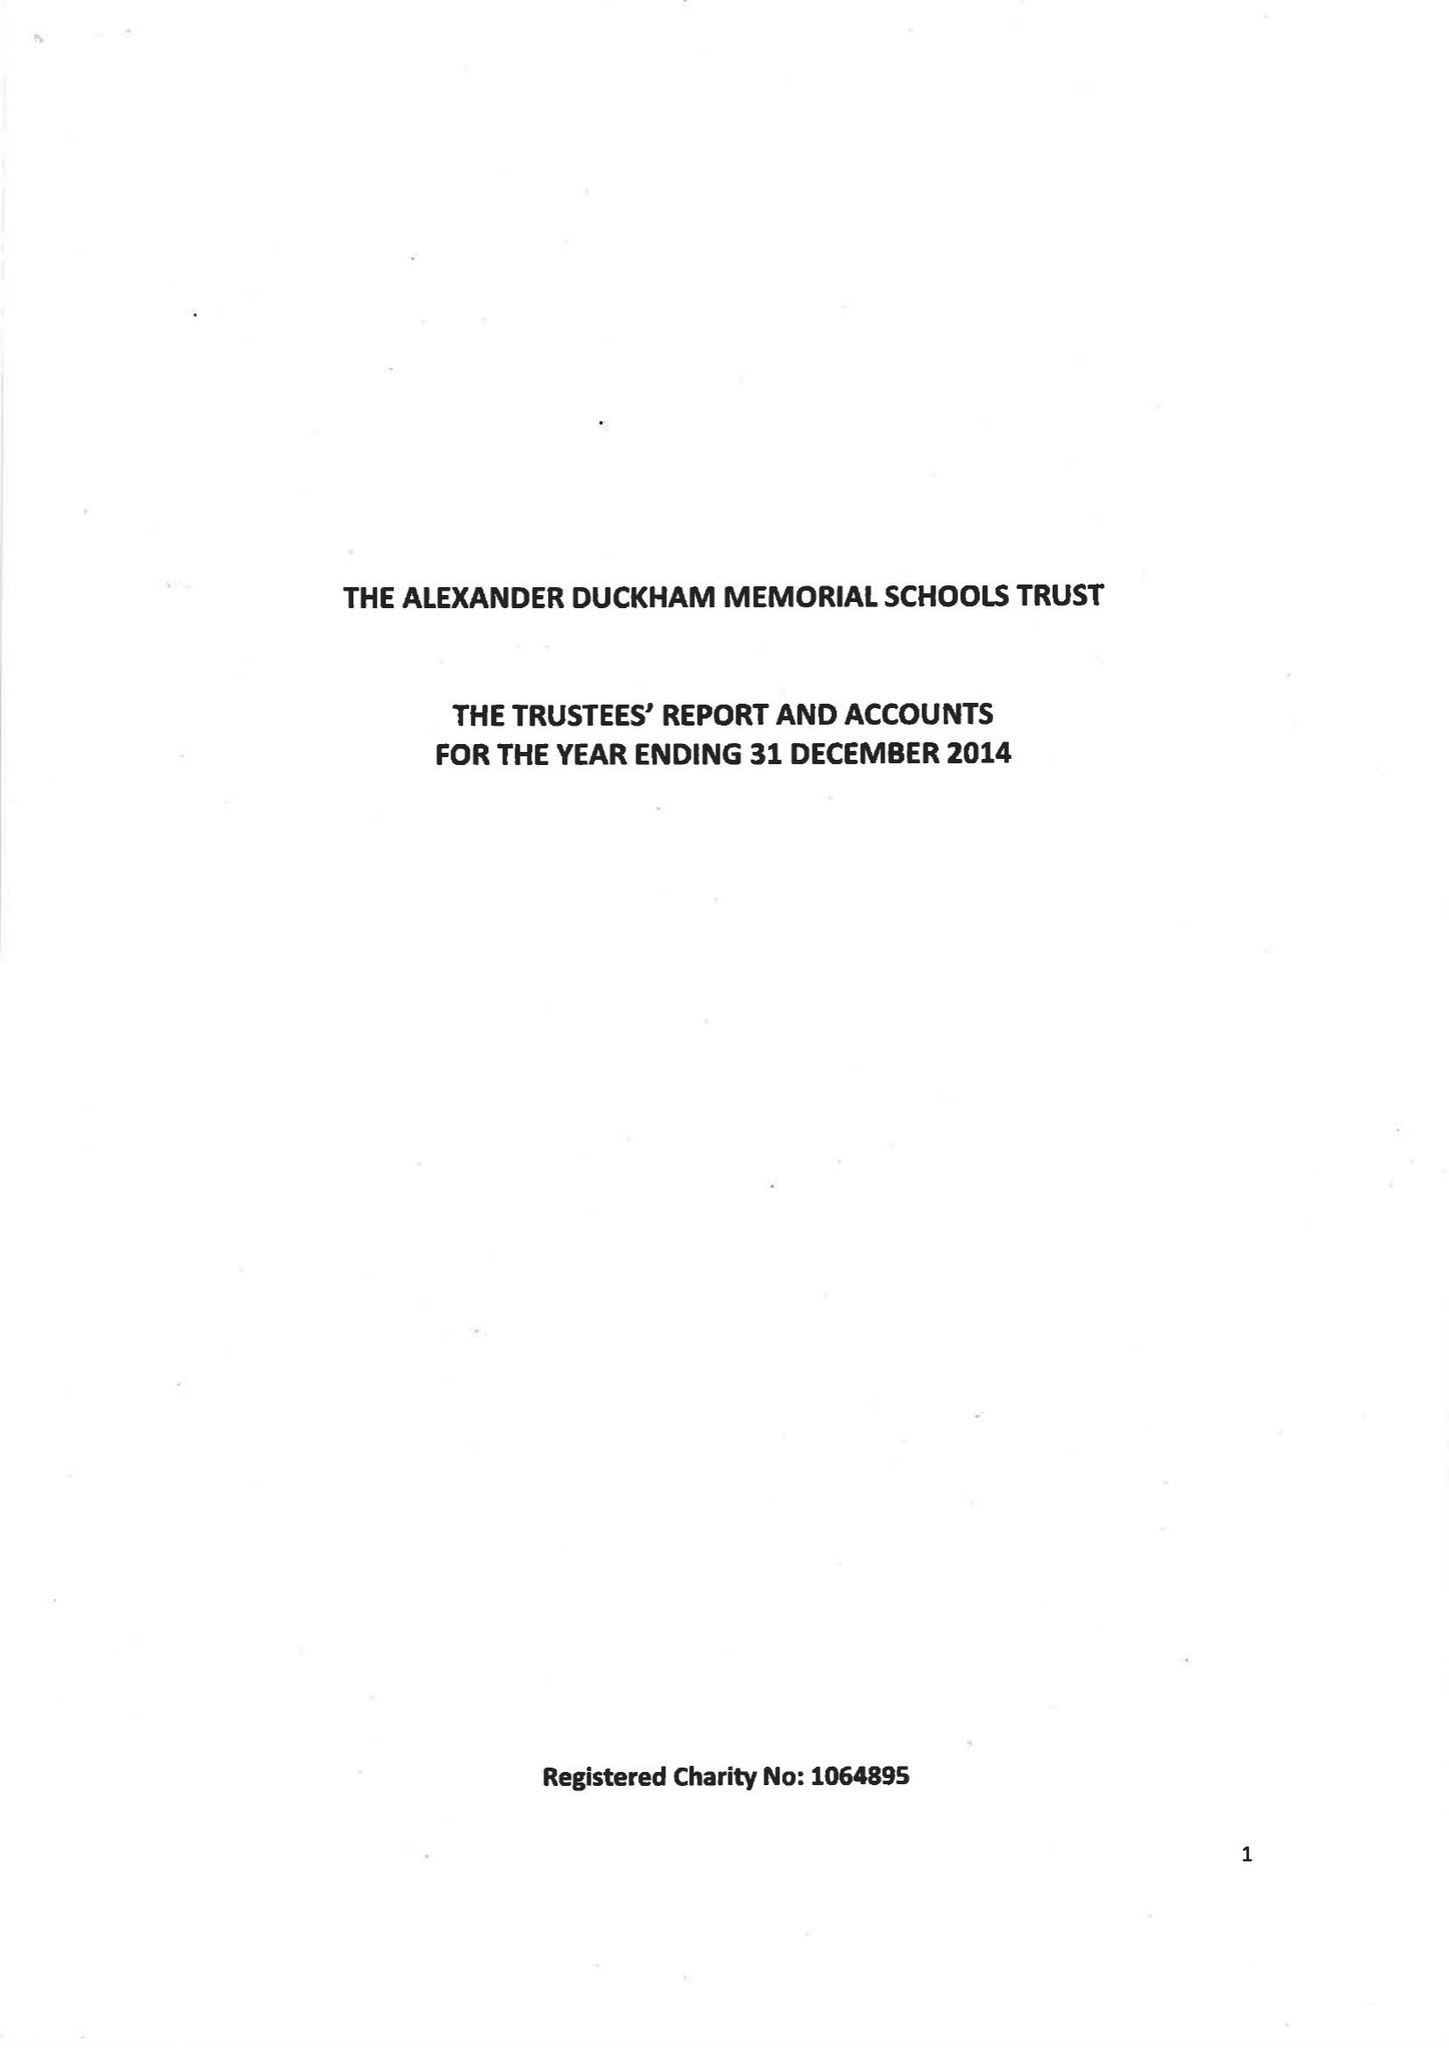What is the value for the address__street_line?
Answer the question using a single word or phrase. None 